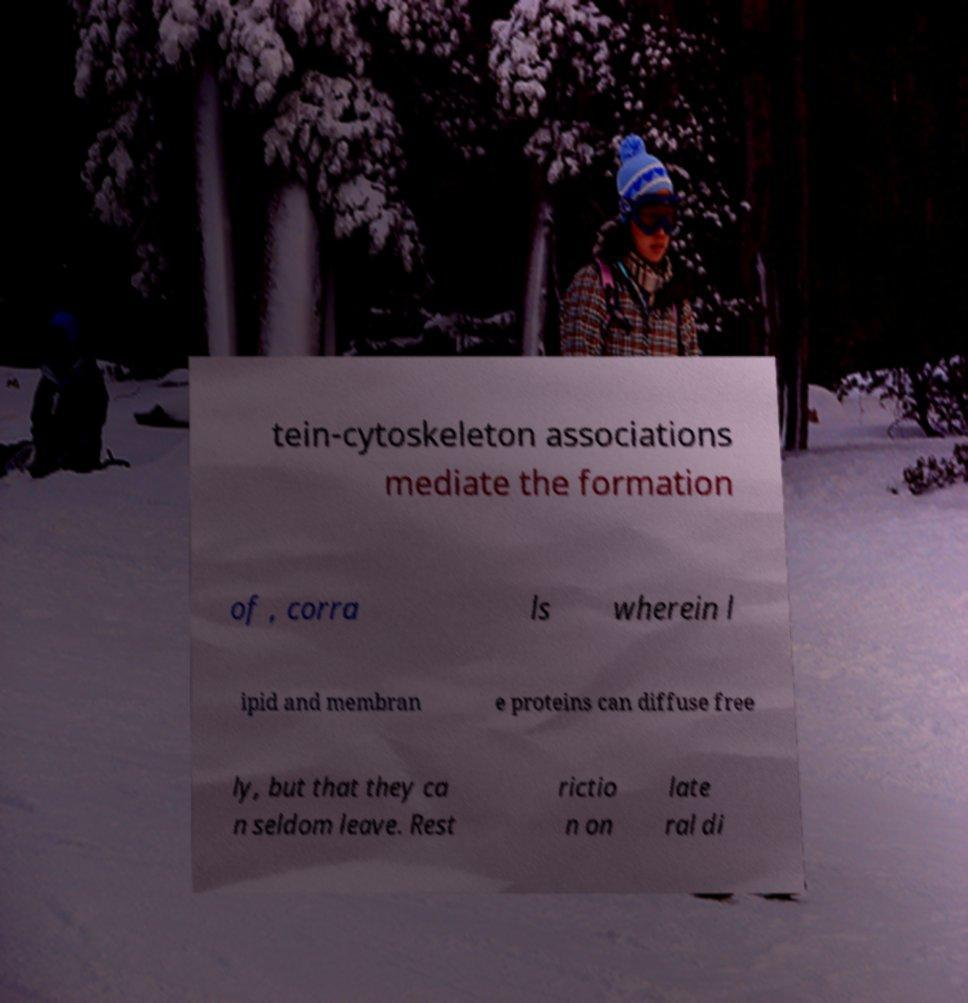For documentation purposes, I need the text within this image transcribed. Could you provide that? tein-cytoskeleton associations mediate the formation of , corra ls wherein l ipid and membran e proteins can diffuse free ly, but that they ca n seldom leave. Rest rictio n on late ral di 